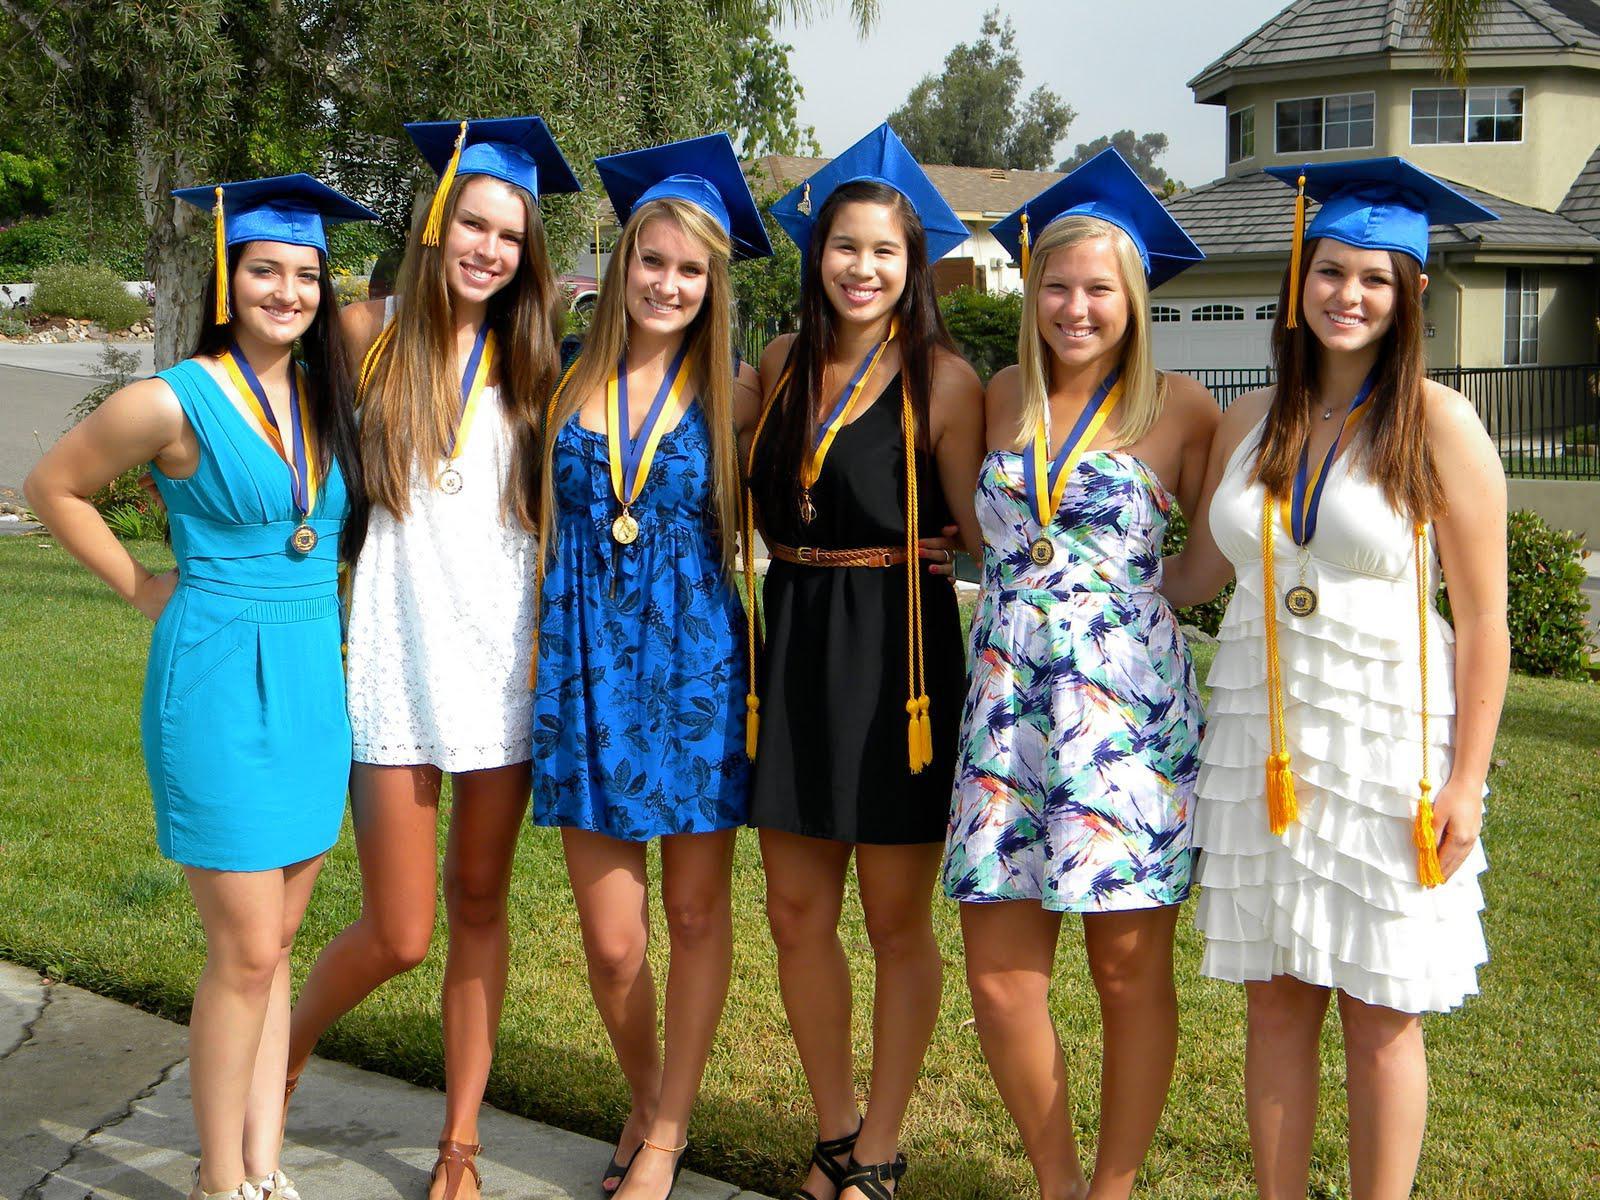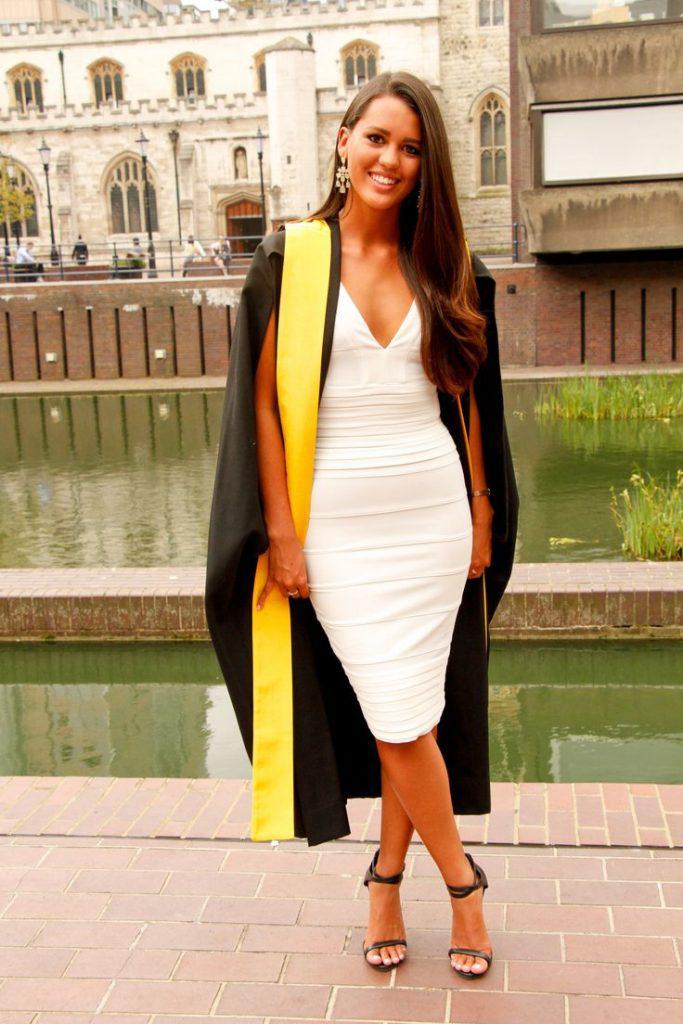The first image is the image on the left, the second image is the image on the right. Given the left and right images, does the statement "There are total of three graduates." hold true? Answer yes or no. No. 